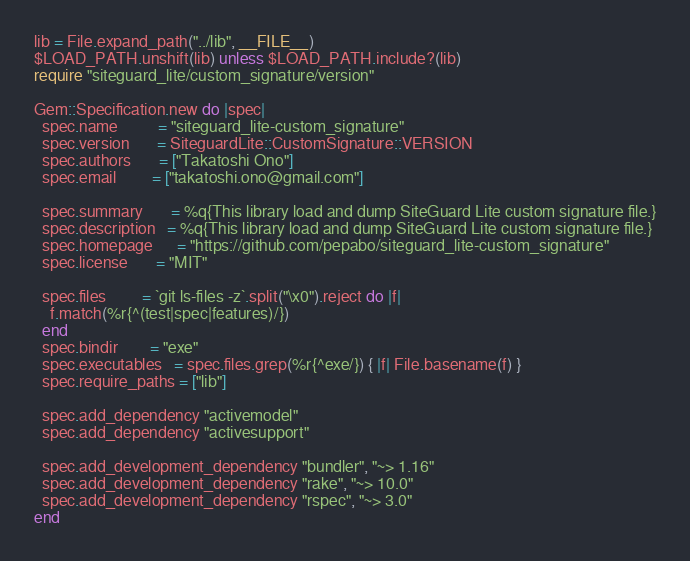Convert code to text. <code><loc_0><loc_0><loc_500><loc_500><_Ruby_>
lib = File.expand_path("../lib", __FILE__)
$LOAD_PATH.unshift(lib) unless $LOAD_PATH.include?(lib)
require "siteguard_lite/custom_signature/version"

Gem::Specification.new do |spec|
  spec.name          = "siteguard_lite-custom_signature"
  spec.version       = SiteguardLite::CustomSignature::VERSION
  spec.authors       = ["Takatoshi Ono"]
  spec.email         = ["takatoshi.ono@gmail.com"]

  spec.summary       = %q{This library load and dump SiteGuard Lite custom signature file.}
  spec.description   = %q{This library load and dump SiteGuard Lite custom signature file.}
  spec.homepage      = "https://github.com/pepabo/siteguard_lite-custom_signature"
  spec.license       = "MIT"

  spec.files         = `git ls-files -z`.split("\x0").reject do |f|
    f.match(%r{^(test|spec|features)/})
  end
  spec.bindir        = "exe"
  spec.executables   = spec.files.grep(%r{^exe/}) { |f| File.basename(f) }
  spec.require_paths = ["lib"]

  spec.add_dependency "activemodel"
  spec.add_dependency "activesupport"

  spec.add_development_dependency "bundler", "~> 1.16"
  spec.add_development_dependency "rake", "~> 10.0"
  spec.add_development_dependency "rspec", "~> 3.0"
end
</code> 